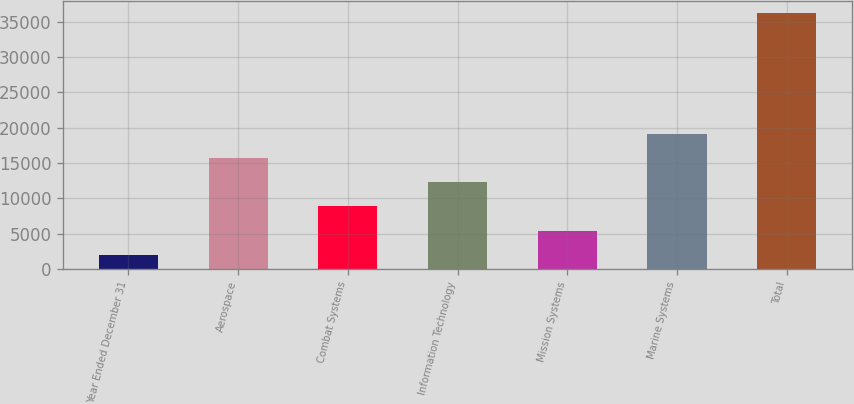Convert chart to OTSL. <chart><loc_0><loc_0><loc_500><loc_500><bar_chart><fcel>Year Ended December 31<fcel>Aerospace<fcel>Combat Systems<fcel>Information Technology<fcel>Mission Systems<fcel>Marine Systems<fcel>Total<nl><fcel>2018<fcel>15688<fcel>8853<fcel>12270.5<fcel>5435.5<fcel>19105.5<fcel>36193<nl></chart> 